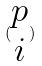<formula> <loc_0><loc_0><loc_500><loc_500>( \begin{matrix} p \\ i \end{matrix} )</formula> 